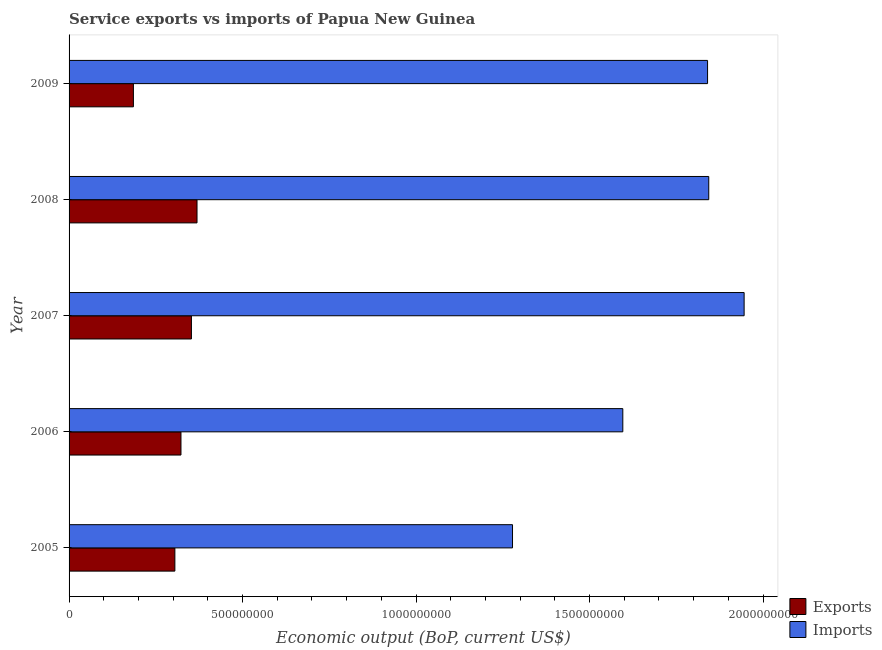How many different coloured bars are there?
Keep it short and to the point. 2. Are the number of bars on each tick of the Y-axis equal?
Offer a very short reply. Yes. How many bars are there on the 5th tick from the bottom?
Provide a succinct answer. 2. What is the amount of service imports in 2006?
Make the answer very short. 1.60e+09. Across all years, what is the maximum amount of service imports?
Provide a succinct answer. 1.95e+09. Across all years, what is the minimum amount of service imports?
Offer a very short reply. 1.28e+09. In which year was the amount of service imports maximum?
Keep it short and to the point. 2007. In which year was the amount of service imports minimum?
Offer a terse response. 2005. What is the total amount of service imports in the graph?
Make the answer very short. 8.50e+09. What is the difference between the amount of service imports in 2008 and that in 2009?
Give a very brief answer. 3.44e+06. What is the difference between the amount of service exports in 2009 and the amount of service imports in 2007?
Make the answer very short. -1.76e+09. What is the average amount of service exports per year?
Provide a short and direct response. 3.07e+08. In the year 2006, what is the difference between the amount of service imports and amount of service exports?
Your answer should be very brief. 1.27e+09. What is the ratio of the amount of service imports in 2006 to that in 2008?
Your response must be concise. 0.87. Is the amount of service exports in 2006 less than that in 2007?
Offer a terse response. Yes. Is the difference between the amount of service imports in 2006 and 2008 greater than the difference between the amount of service exports in 2006 and 2008?
Give a very brief answer. No. What is the difference between the highest and the second highest amount of service exports?
Ensure brevity in your answer.  1.61e+07. What is the difference between the highest and the lowest amount of service imports?
Make the answer very short. 6.67e+08. In how many years, is the amount of service imports greater than the average amount of service imports taken over all years?
Offer a very short reply. 3. What does the 2nd bar from the top in 2007 represents?
Ensure brevity in your answer.  Exports. What does the 1st bar from the bottom in 2008 represents?
Give a very brief answer. Exports. How many bars are there?
Provide a short and direct response. 10. Are all the bars in the graph horizontal?
Your answer should be very brief. Yes. How many years are there in the graph?
Offer a very short reply. 5. What is the difference between two consecutive major ticks on the X-axis?
Give a very brief answer. 5.00e+08. Does the graph contain any zero values?
Keep it short and to the point. No. What is the title of the graph?
Provide a succinct answer. Service exports vs imports of Papua New Guinea. Does "Foreign liabilities" appear as one of the legend labels in the graph?
Your answer should be very brief. No. What is the label or title of the X-axis?
Provide a short and direct response. Economic output (BoP, current US$). What is the label or title of the Y-axis?
Your answer should be very brief. Year. What is the Economic output (BoP, current US$) in Exports in 2005?
Your response must be concise. 3.05e+08. What is the Economic output (BoP, current US$) of Imports in 2005?
Ensure brevity in your answer.  1.28e+09. What is the Economic output (BoP, current US$) of Exports in 2006?
Give a very brief answer. 3.22e+08. What is the Economic output (BoP, current US$) in Imports in 2006?
Provide a short and direct response. 1.60e+09. What is the Economic output (BoP, current US$) in Exports in 2007?
Offer a very short reply. 3.53e+08. What is the Economic output (BoP, current US$) of Imports in 2007?
Provide a succinct answer. 1.95e+09. What is the Economic output (BoP, current US$) of Exports in 2008?
Your response must be concise. 3.69e+08. What is the Economic output (BoP, current US$) in Imports in 2008?
Give a very brief answer. 1.84e+09. What is the Economic output (BoP, current US$) of Exports in 2009?
Your answer should be very brief. 1.85e+08. What is the Economic output (BoP, current US$) in Imports in 2009?
Make the answer very short. 1.84e+09. Across all years, what is the maximum Economic output (BoP, current US$) of Exports?
Give a very brief answer. 3.69e+08. Across all years, what is the maximum Economic output (BoP, current US$) in Imports?
Give a very brief answer. 1.95e+09. Across all years, what is the minimum Economic output (BoP, current US$) of Exports?
Offer a very short reply. 1.85e+08. Across all years, what is the minimum Economic output (BoP, current US$) in Imports?
Provide a succinct answer. 1.28e+09. What is the total Economic output (BoP, current US$) of Exports in the graph?
Your answer should be compact. 1.53e+09. What is the total Economic output (BoP, current US$) of Imports in the graph?
Give a very brief answer. 8.50e+09. What is the difference between the Economic output (BoP, current US$) of Exports in 2005 and that in 2006?
Offer a terse response. -1.76e+07. What is the difference between the Economic output (BoP, current US$) of Imports in 2005 and that in 2006?
Offer a terse response. -3.18e+08. What is the difference between the Economic output (BoP, current US$) in Exports in 2005 and that in 2007?
Provide a short and direct response. -4.77e+07. What is the difference between the Economic output (BoP, current US$) of Imports in 2005 and that in 2007?
Your answer should be compact. -6.67e+08. What is the difference between the Economic output (BoP, current US$) in Exports in 2005 and that in 2008?
Offer a terse response. -6.38e+07. What is the difference between the Economic output (BoP, current US$) in Imports in 2005 and that in 2008?
Give a very brief answer. -5.66e+08. What is the difference between the Economic output (BoP, current US$) of Exports in 2005 and that in 2009?
Offer a very short reply. 1.20e+08. What is the difference between the Economic output (BoP, current US$) in Imports in 2005 and that in 2009?
Offer a very short reply. -5.62e+08. What is the difference between the Economic output (BoP, current US$) in Exports in 2006 and that in 2007?
Your answer should be compact. -3.01e+07. What is the difference between the Economic output (BoP, current US$) of Imports in 2006 and that in 2007?
Provide a succinct answer. -3.50e+08. What is the difference between the Economic output (BoP, current US$) in Exports in 2006 and that in 2008?
Your answer should be compact. -4.63e+07. What is the difference between the Economic output (BoP, current US$) in Imports in 2006 and that in 2008?
Make the answer very short. -2.48e+08. What is the difference between the Economic output (BoP, current US$) in Exports in 2006 and that in 2009?
Offer a terse response. 1.37e+08. What is the difference between the Economic output (BoP, current US$) in Imports in 2006 and that in 2009?
Make the answer very short. -2.44e+08. What is the difference between the Economic output (BoP, current US$) in Exports in 2007 and that in 2008?
Keep it short and to the point. -1.61e+07. What is the difference between the Economic output (BoP, current US$) of Imports in 2007 and that in 2008?
Your answer should be compact. 1.02e+08. What is the difference between the Economic output (BoP, current US$) in Exports in 2007 and that in 2009?
Ensure brevity in your answer.  1.67e+08. What is the difference between the Economic output (BoP, current US$) of Imports in 2007 and that in 2009?
Give a very brief answer. 1.05e+08. What is the difference between the Economic output (BoP, current US$) in Exports in 2008 and that in 2009?
Provide a short and direct response. 1.83e+08. What is the difference between the Economic output (BoP, current US$) in Imports in 2008 and that in 2009?
Keep it short and to the point. 3.44e+06. What is the difference between the Economic output (BoP, current US$) in Exports in 2005 and the Economic output (BoP, current US$) in Imports in 2006?
Offer a terse response. -1.29e+09. What is the difference between the Economic output (BoP, current US$) in Exports in 2005 and the Economic output (BoP, current US$) in Imports in 2007?
Make the answer very short. -1.64e+09. What is the difference between the Economic output (BoP, current US$) in Exports in 2005 and the Economic output (BoP, current US$) in Imports in 2008?
Provide a short and direct response. -1.54e+09. What is the difference between the Economic output (BoP, current US$) of Exports in 2005 and the Economic output (BoP, current US$) of Imports in 2009?
Offer a terse response. -1.54e+09. What is the difference between the Economic output (BoP, current US$) in Exports in 2006 and the Economic output (BoP, current US$) in Imports in 2007?
Give a very brief answer. -1.62e+09. What is the difference between the Economic output (BoP, current US$) in Exports in 2006 and the Economic output (BoP, current US$) in Imports in 2008?
Your answer should be very brief. -1.52e+09. What is the difference between the Economic output (BoP, current US$) of Exports in 2006 and the Economic output (BoP, current US$) of Imports in 2009?
Your response must be concise. -1.52e+09. What is the difference between the Economic output (BoP, current US$) of Exports in 2007 and the Economic output (BoP, current US$) of Imports in 2008?
Ensure brevity in your answer.  -1.49e+09. What is the difference between the Economic output (BoP, current US$) in Exports in 2007 and the Economic output (BoP, current US$) in Imports in 2009?
Ensure brevity in your answer.  -1.49e+09. What is the difference between the Economic output (BoP, current US$) in Exports in 2008 and the Economic output (BoP, current US$) in Imports in 2009?
Your answer should be very brief. -1.47e+09. What is the average Economic output (BoP, current US$) in Exports per year?
Keep it short and to the point. 3.07e+08. What is the average Economic output (BoP, current US$) of Imports per year?
Your answer should be very brief. 1.70e+09. In the year 2005, what is the difference between the Economic output (BoP, current US$) of Exports and Economic output (BoP, current US$) of Imports?
Your response must be concise. -9.73e+08. In the year 2006, what is the difference between the Economic output (BoP, current US$) of Exports and Economic output (BoP, current US$) of Imports?
Your answer should be compact. -1.27e+09. In the year 2007, what is the difference between the Economic output (BoP, current US$) in Exports and Economic output (BoP, current US$) in Imports?
Provide a short and direct response. -1.59e+09. In the year 2008, what is the difference between the Economic output (BoP, current US$) in Exports and Economic output (BoP, current US$) in Imports?
Your response must be concise. -1.47e+09. In the year 2009, what is the difference between the Economic output (BoP, current US$) in Exports and Economic output (BoP, current US$) in Imports?
Keep it short and to the point. -1.65e+09. What is the ratio of the Economic output (BoP, current US$) of Exports in 2005 to that in 2006?
Keep it short and to the point. 0.95. What is the ratio of the Economic output (BoP, current US$) in Imports in 2005 to that in 2006?
Ensure brevity in your answer.  0.8. What is the ratio of the Economic output (BoP, current US$) of Exports in 2005 to that in 2007?
Make the answer very short. 0.86. What is the ratio of the Economic output (BoP, current US$) of Imports in 2005 to that in 2007?
Make the answer very short. 0.66. What is the ratio of the Economic output (BoP, current US$) in Exports in 2005 to that in 2008?
Offer a terse response. 0.83. What is the ratio of the Economic output (BoP, current US$) of Imports in 2005 to that in 2008?
Give a very brief answer. 0.69. What is the ratio of the Economic output (BoP, current US$) of Exports in 2005 to that in 2009?
Offer a very short reply. 1.64. What is the ratio of the Economic output (BoP, current US$) of Imports in 2005 to that in 2009?
Offer a terse response. 0.69. What is the ratio of the Economic output (BoP, current US$) in Exports in 2006 to that in 2007?
Ensure brevity in your answer.  0.91. What is the ratio of the Economic output (BoP, current US$) of Imports in 2006 to that in 2007?
Give a very brief answer. 0.82. What is the ratio of the Economic output (BoP, current US$) of Exports in 2006 to that in 2008?
Your response must be concise. 0.87. What is the ratio of the Economic output (BoP, current US$) in Imports in 2006 to that in 2008?
Keep it short and to the point. 0.87. What is the ratio of the Economic output (BoP, current US$) of Exports in 2006 to that in 2009?
Your answer should be very brief. 1.74. What is the ratio of the Economic output (BoP, current US$) in Imports in 2006 to that in 2009?
Offer a very short reply. 0.87. What is the ratio of the Economic output (BoP, current US$) of Exports in 2007 to that in 2008?
Provide a short and direct response. 0.96. What is the ratio of the Economic output (BoP, current US$) in Imports in 2007 to that in 2008?
Keep it short and to the point. 1.06. What is the ratio of the Economic output (BoP, current US$) in Exports in 2007 to that in 2009?
Your response must be concise. 1.9. What is the ratio of the Economic output (BoP, current US$) of Imports in 2007 to that in 2009?
Keep it short and to the point. 1.06. What is the ratio of the Economic output (BoP, current US$) of Exports in 2008 to that in 2009?
Offer a terse response. 1.99. What is the difference between the highest and the second highest Economic output (BoP, current US$) in Exports?
Your answer should be compact. 1.61e+07. What is the difference between the highest and the second highest Economic output (BoP, current US$) of Imports?
Provide a short and direct response. 1.02e+08. What is the difference between the highest and the lowest Economic output (BoP, current US$) in Exports?
Make the answer very short. 1.83e+08. What is the difference between the highest and the lowest Economic output (BoP, current US$) of Imports?
Your answer should be compact. 6.67e+08. 